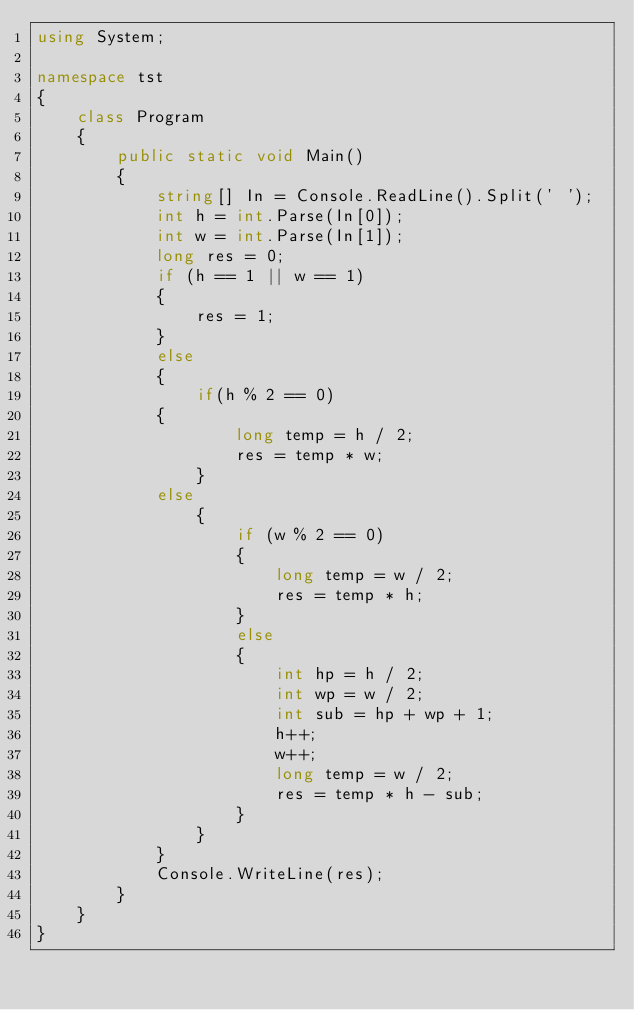Convert code to text. <code><loc_0><loc_0><loc_500><loc_500><_C#_>using System;

namespace tst
{
    class Program
    {
        public static void Main()
        {
            string[] In = Console.ReadLine().Split(' ');
            int h = int.Parse(In[0]);
            int w = int.Parse(In[1]);
            long res = 0;
            if (h == 1 || w == 1)
            {
                res = 1;
            }
            else
            {
                if(h % 2 == 0)
            {
                    long temp = h / 2;
                    res = temp * w;
                }
            else
                {
                    if (w % 2 == 0)
                    {
                        long temp = w / 2;
                        res = temp * h;
                    }
                    else
                    {
                        int hp = h / 2;
                        int wp = w / 2;
                        int sub = hp + wp + 1;
                        h++;
                        w++;
                        long temp = w / 2;
                        res = temp * h - sub;
                    }
                }
            }
            Console.WriteLine(res);
        }
    }
}</code> 